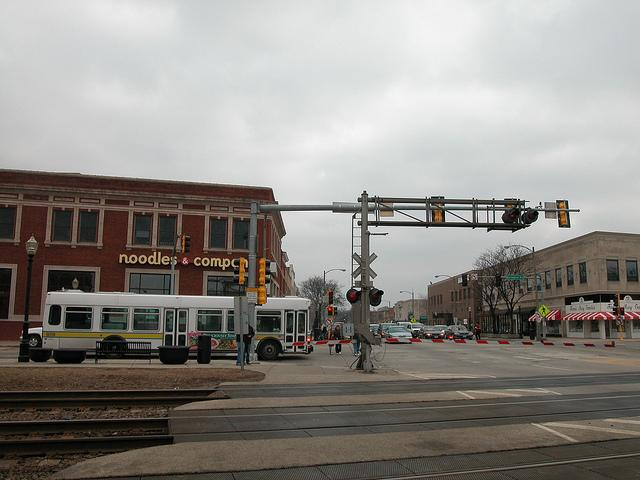What is causing traffic to stop? Please explain your reasoning. oncoming train. There is a train crossing and the arms to prevent traffic are seen down here. 